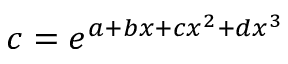<formula> <loc_0><loc_0><loc_500><loc_500>c = e ^ { a + b x + c x ^ { 2 } + d x ^ { 3 } }</formula> 